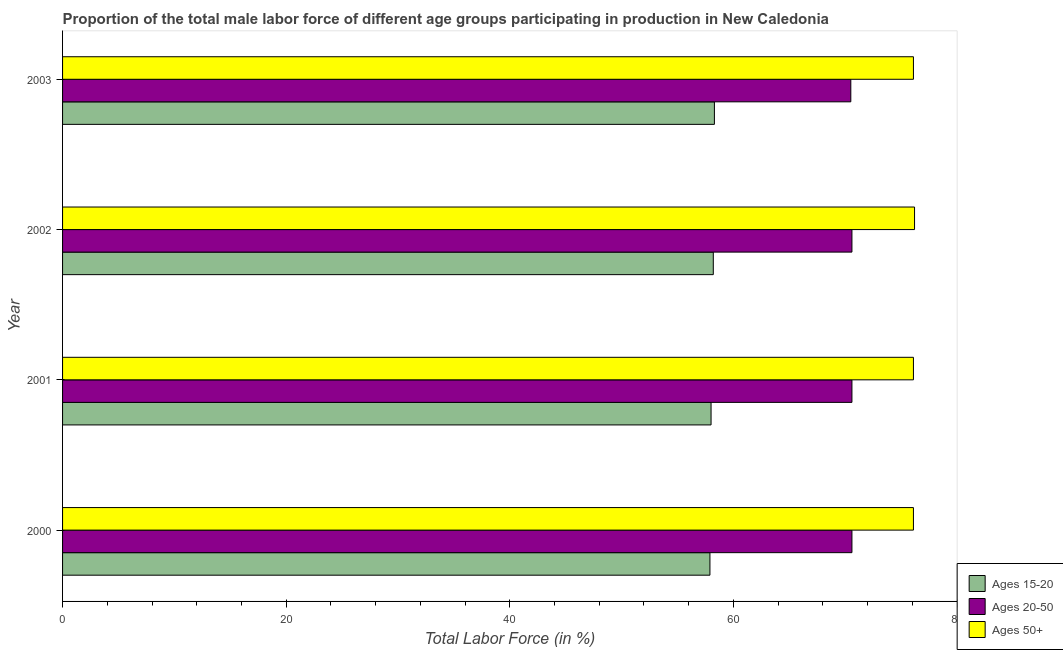How many groups of bars are there?
Keep it short and to the point. 4. How many bars are there on the 4th tick from the top?
Ensure brevity in your answer.  3. In how many cases, is the number of bars for a given year not equal to the number of legend labels?
Ensure brevity in your answer.  0. What is the percentage of male labor force within the age group 20-50 in 2003?
Provide a short and direct response. 70.5. Across all years, what is the maximum percentage of male labor force within the age group 15-20?
Offer a very short reply. 58.3. Across all years, what is the minimum percentage of male labor force within the age group 15-20?
Give a very brief answer. 57.9. In which year was the percentage of male labor force within the age group 20-50 maximum?
Provide a succinct answer. 2000. What is the total percentage of male labor force within the age group 15-20 in the graph?
Provide a short and direct response. 232.4. What is the difference between the percentage of male labor force within the age group 15-20 in 2001 and the percentage of male labor force above age 50 in 2003?
Give a very brief answer. -18.1. What is the average percentage of male labor force above age 50 per year?
Ensure brevity in your answer.  76.12. Is the difference between the percentage of male labor force within the age group 15-20 in 2002 and 2003 greater than the difference between the percentage of male labor force above age 50 in 2002 and 2003?
Offer a terse response. No. Is the sum of the percentage of male labor force within the age group 20-50 in 2000 and 2003 greater than the maximum percentage of male labor force within the age group 15-20 across all years?
Provide a short and direct response. Yes. What does the 3rd bar from the top in 2001 represents?
Offer a terse response. Ages 15-20. What does the 3rd bar from the bottom in 2003 represents?
Your answer should be very brief. Ages 50+. Is it the case that in every year, the sum of the percentage of male labor force within the age group 15-20 and percentage of male labor force within the age group 20-50 is greater than the percentage of male labor force above age 50?
Your answer should be very brief. Yes. How many bars are there?
Make the answer very short. 12. Are all the bars in the graph horizontal?
Offer a very short reply. Yes. How many years are there in the graph?
Your answer should be very brief. 4. What is the title of the graph?
Give a very brief answer. Proportion of the total male labor force of different age groups participating in production in New Caledonia. Does "Capital account" appear as one of the legend labels in the graph?
Provide a short and direct response. No. What is the label or title of the X-axis?
Your response must be concise. Total Labor Force (in %). What is the label or title of the Y-axis?
Your answer should be very brief. Year. What is the Total Labor Force (in %) in Ages 15-20 in 2000?
Make the answer very short. 57.9. What is the Total Labor Force (in %) of Ages 20-50 in 2000?
Provide a short and direct response. 70.6. What is the Total Labor Force (in %) of Ages 50+ in 2000?
Offer a terse response. 76.1. What is the Total Labor Force (in %) of Ages 15-20 in 2001?
Offer a very short reply. 58. What is the Total Labor Force (in %) in Ages 20-50 in 2001?
Offer a very short reply. 70.6. What is the Total Labor Force (in %) of Ages 50+ in 2001?
Offer a terse response. 76.1. What is the Total Labor Force (in %) of Ages 15-20 in 2002?
Offer a terse response. 58.2. What is the Total Labor Force (in %) of Ages 20-50 in 2002?
Offer a terse response. 70.6. What is the Total Labor Force (in %) in Ages 50+ in 2002?
Give a very brief answer. 76.2. What is the Total Labor Force (in %) in Ages 15-20 in 2003?
Keep it short and to the point. 58.3. What is the Total Labor Force (in %) in Ages 20-50 in 2003?
Offer a terse response. 70.5. What is the Total Labor Force (in %) in Ages 50+ in 2003?
Provide a succinct answer. 76.1. Across all years, what is the maximum Total Labor Force (in %) of Ages 15-20?
Keep it short and to the point. 58.3. Across all years, what is the maximum Total Labor Force (in %) in Ages 20-50?
Keep it short and to the point. 70.6. Across all years, what is the maximum Total Labor Force (in %) in Ages 50+?
Make the answer very short. 76.2. Across all years, what is the minimum Total Labor Force (in %) of Ages 15-20?
Ensure brevity in your answer.  57.9. Across all years, what is the minimum Total Labor Force (in %) of Ages 20-50?
Your answer should be compact. 70.5. Across all years, what is the minimum Total Labor Force (in %) of Ages 50+?
Offer a very short reply. 76.1. What is the total Total Labor Force (in %) in Ages 15-20 in the graph?
Ensure brevity in your answer.  232.4. What is the total Total Labor Force (in %) in Ages 20-50 in the graph?
Keep it short and to the point. 282.3. What is the total Total Labor Force (in %) in Ages 50+ in the graph?
Offer a very short reply. 304.5. What is the difference between the Total Labor Force (in %) of Ages 15-20 in 2000 and that in 2001?
Offer a very short reply. -0.1. What is the difference between the Total Labor Force (in %) in Ages 20-50 in 2000 and that in 2001?
Provide a short and direct response. 0. What is the difference between the Total Labor Force (in %) in Ages 50+ in 2000 and that in 2001?
Your answer should be very brief. 0. What is the difference between the Total Labor Force (in %) in Ages 15-20 in 2000 and that in 2002?
Your answer should be compact. -0.3. What is the difference between the Total Labor Force (in %) in Ages 50+ in 2000 and that in 2002?
Provide a succinct answer. -0.1. What is the difference between the Total Labor Force (in %) in Ages 20-50 in 2000 and that in 2003?
Keep it short and to the point. 0.1. What is the difference between the Total Labor Force (in %) of Ages 15-20 in 2001 and that in 2002?
Provide a short and direct response. -0.2. What is the difference between the Total Labor Force (in %) in Ages 20-50 in 2001 and that in 2002?
Give a very brief answer. 0. What is the difference between the Total Labor Force (in %) of Ages 20-50 in 2001 and that in 2003?
Give a very brief answer. 0.1. What is the difference between the Total Labor Force (in %) of Ages 50+ in 2001 and that in 2003?
Provide a short and direct response. 0. What is the difference between the Total Labor Force (in %) in Ages 15-20 in 2002 and that in 2003?
Make the answer very short. -0.1. What is the difference between the Total Labor Force (in %) in Ages 15-20 in 2000 and the Total Labor Force (in %) in Ages 20-50 in 2001?
Ensure brevity in your answer.  -12.7. What is the difference between the Total Labor Force (in %) in Ages 15-20 in 2000 and the Total Labor Force (in %) in Ages 50+ in 2001?
Ensure brevity in your answer.  -18.2. What is the difference between the Total Labor Force (in %) in Ages 15-20 in 2000 and the Total Labor Force (in %) in Ages 50+ in 2002?
Keep it short and to the point. -18.3. What is the difference between the Total Labor Force (in %) of Ages 20-50 in 2000 and the Total Labor Force (in %) of Ages 50+ in 2002?
Your answer should be very brief. -5.6. What is the difference between the Total Labor Force (in %) in Ages 15-20 in 2000 and the Total Labor Force (in %) in Ages 50+ in 2003?
Make the answer very short. -18.2. What is the difference between the Total Labor Force (in %) of Ages 15-20 in 2001 and the Total Labor Force (in %) of Ages 50+ in 2002?
Provide a short and direct response. -18.2. What is the difference between the Total Labor Force (in %) of Ages 20-50 in 2001 and the Total Labor Force (in %) of Ages 50+ in 2002?
Keep it short and to the point. -5.6. What is the difference between the Total Labor Force (in %) in Ages 15-20 in 2001 and the Total Labor Force (in %) in Ages 50+ in 2003?
Ensure brevity in your answer.  -18.1. What is the difference between the Total Labor Force (in %) in Ages 20-50 in 2001 and the Total Labor Force (in %) in Ages 50+ in 2003?
Keep it short and to the point. -5.5. What is the difference between the Total Labor Force (in %) in Ages 15-20 in 2002 and the Total Labor Force (in %) in Ages 20-50 in 2003?
Ensure brevity in your answer.  -12.3. What is the difference between the Total Labor Force (in %) in Ages 15-20 in 2002 and the Total Labor Force (in %) in Ages 50+ in 2003?
Ensure brevity in your answer.  -17.9. What is the average Total Labor Force (in %) in Ages 15-20 per year?
Offer a terse response. 58.1. What is the average Total Labor Force (in %) of Ages 20-50 per year?
Provide a short and direct response. 70.58. What is the average Total Labor Force (in %) of Ages 50+ per year?
Provide a succinct answer. 76.12. In the year 2000, what is the difference between the Total Labor Force (in %) of Ages 15-20 and Total Labor Force (in %) of Ages 50+?
Ensure brevity in your answer.  -18.2. In the year 2000, what is the difference between the Total Labor Force (in %) in Ages 20-50 and Total Labor Force (in %) in Ages 50+?
Provide a succinct answer. -5.5. In the year 2001, what is the difference between the Total Labor Force (in %) of Ages 15-20 and Total Labor Force (in %) of Ages 50+?
Offer a very short reply. -18.1. In the year 2003, what is the difference between the Total Labor Force (in %) in Ages 15-20 and Total Labor Force (in %) in Ages 50+?
Keep it short and to the point. -17.8. What is the ratio of the Total Labor Force (in %) in Ages 15-20 in 2000 to that in 2001?
Give a very brief answer. 1. What is the ratio of the Total Labor Force (in %) of Ages 20-50 in 2000 to that in 2002?
Your answer should be compact. 1. What is the ratio of the Total Labor Force (in %) of Ages 15-20 in 2000 to that in 2003?
Offer a very short reply. 0.99. What is the ratio of the Total Labor Force (in %) of Ages 20-50 in 2000 to that in 2003?
Your response must be concise. 1. What is the ratio of the Total Labor Force (in %) in Ages 50+ in 2001 to that in 2002?
Give a very brief answer. 1. What is the ratio of the Total Labor Force (in %) in Ages 15-20 in 2001 to that in 2003?
Provide a succinct answer. 0.99. What is the ratio of the Total Labor Force (in %) of Ages 20-50 in 2001 to that in 2003?
Ensure brevity in your answer.  1. What is the ratio of the Total Labor Force (in %) of Ages 50+ in 2002 to that in 2003?
Your answer should be compact. 1. What is the difference between the highest and the second highest Total Labor Force (in %) of Ages 15-20?
Your response must be concise. 0.1. What is the difference between the highest and the second highest Total Labor Force (in %) of Ages 20-50?
Your answer should be compact. 0. What is the difference between the highest and the lowest Total Labor Force (in %) of Ages 20-50?
Provide a succinct answer. 0.1. 